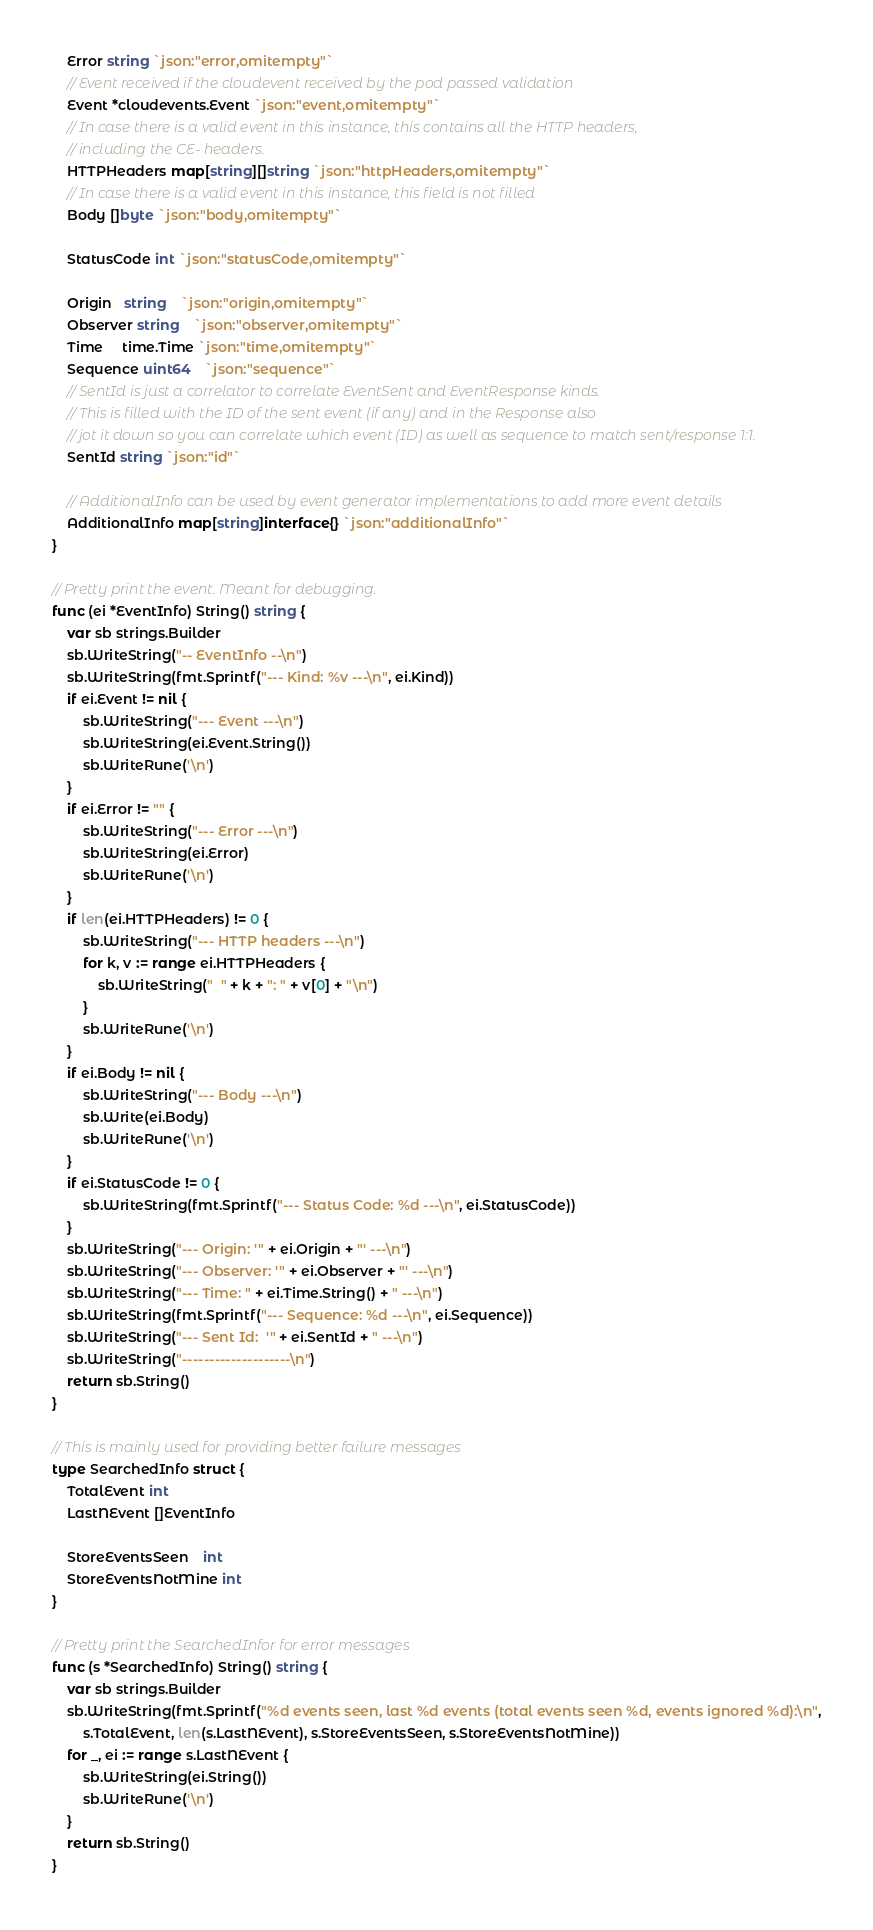<code> <loc_0><loc_0><loc_500><loc_500><_Go_>	Error string `json:"error,omitempty"`
	// Event received if the cloudevent received by the pod passed validation
	Event *cloudevents.Event `json:"event,omitempty"`
	// In case there is a valid event in this instance, this contains all the HTTP headers,
	// including the CE- headers.
	HTTPHeaders map[string][]string `json:"httpHeaders,omitempty"`
	// In case there is a valid event in this instance, this field is not filled
	Body []byte `json:"body,omitempty"`

	StatusCode int `json:"statusCode,omitempty"`

	Origin   string    `json:"origin,omitempty"`
	Observer string    `json:"observer,omitempty"`
	Time     time.Time `json:"time,omitempty"`
	Sequence uint64    `json:"sequence"`
	// SentId is just a correlator to correlate EventSent and EventResponse kinds.
	// This is filled with the ID of the sent event (if any) and in the Response also
	// jot it down so you can correlate which event (ID) as well as sequence to match sent/response 1:1.
	SentId string `json:"id"`

	// AdditionalInfo can be used by event generator implementations to add more event details
	AdditionalInfo map[string]interface{} `json:"additionalInfo"`
}

// Pretty print the event. Meant for debugging.
func (ei *EventInfo) String() string {
	var sb strings.Builder
	sb.WriteString("-- EventInfo --\n")
	sb.WriteString(fmt.Sprintf("--- Kind: %v ---\n", ei.Kind))
	if ei.Event != nil {
		sb.WriteString("--- Event ---\n")
		sb.WriteString(ei.Event.String())
		sb.WriteRune('\n')
	}
	if ei.Error != "" {
		sb.WriteString("--- Error ---\n")
		sb.WriteString(ei.Error)
		sb.WriteRune('\n')
	}
	if len(ei.HTTPHeaders) != 0 {
		sb.WriteString("--- HTTP headers ---\n")
		for k, v := range ei.HTTPHeaders {
			sb.WriteString("  " + k + ": " + v[0] + "\n")
		}
		sb.WriteRune('\n')
	}
	if ei.Body != nil {
		sb.WriteString("--- Body ---\n")
		sb.Write(ei.Body)
		sb.WriteRune('\n')
	}
	if ei.StatusCode != 0 {
		sb.WriteString(fmt.Sprintf("--- Status Code: %d ---\n", ei.StatusCode))
	}
	sb.WriteString("--- Origin: '" + ei.Origin + "' ---\n")
	sb.WriteString("--- Observer: '" + ei.Observer + "' ---\n")
	sb.WriteString("--- Time: " + ei.Time.String() + " ---\n")
	sb.WriteString(fmt.Sprintf("--- Sequence: %d ---\n", ei.Sequence))
	sb.WriteString("--- Sent Id:  '" + ei.SentId + " ---\n")
	sb.WriteString("--------------------\n")
	return sb.String()
}

// This is mainly used for providing better failure messages
type SearchedInfo struct {
	TotalEvent int
	LastNEvent []EventInfo

	StoreEventsSeen    int
	StoreEventsNotMine int
}

// Pretty print the SearchedInfor for error messages
func (s *SearchedInfo) String() string {
	var sb strings.Builder
	sb.WriteString(fmt.Sprintf("%d events seen, last %d events (total events seen %d, events ignored %d):\n",
		s.TotalEvent, len(s.LastNEvent), s.StoreEventsSeen, s.StoreEventsNotMine))
	for _, ei := range s.LastNEvent {
		sb.WriteString(ei.String())
		sb.WriteRune('\n')
	}
	return sb.String()
}
</code> 